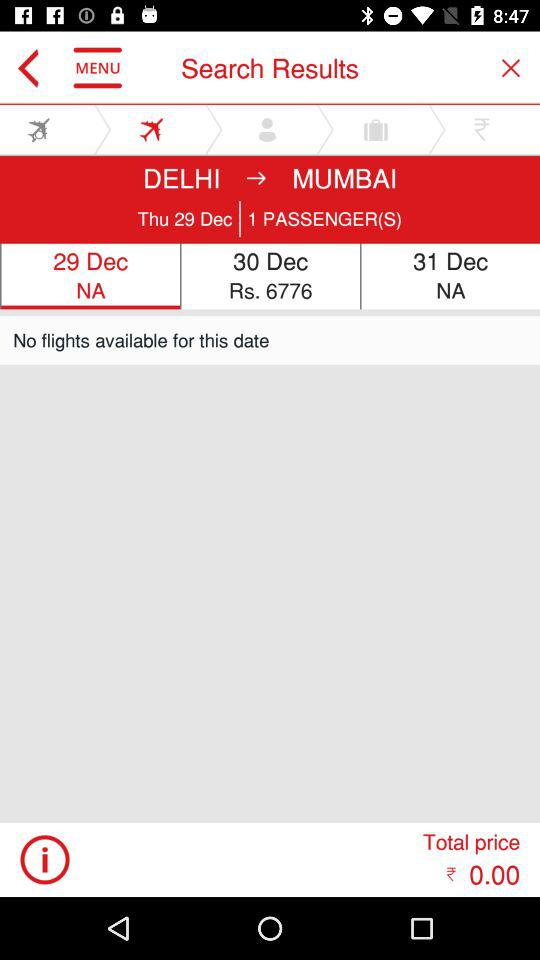Are there any flights available on December 30?
When the provided information is insufficient, respond with <no answer>. <no answer> 